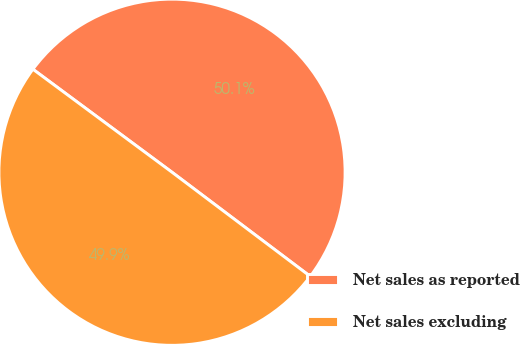Convert chart. <chart><loc_0><loc_0><loc_500><loc_500><pie_chart><fcel>Net sales as reported<fcel>Net sales excluding<nl><fcel>50.13%<fcel>49.87%<nl></chart> 